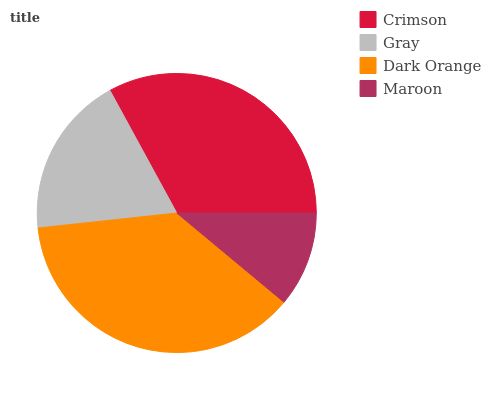Is Maroon the minimum?
Answer yes or no. Yes. Is Dark Orange the maximum?
Answer yes or no. Yes. Is Gray the minimum?
Answer yes or no. No. Is Gray the maximum?
Answer yes or no. No. Is Crimson greater than Gray?
Answer yes or no. Yes. Is Gray less than Crimson?
Answer yes or no. Yes. Is Gray greater than Crimson?
Answer yes or no. No. Is Crimson less than Gray?
Answer yes or no. No. Is Crimson the high median?
Answer yes or no. Yes. Is Gray the low median?
Answer yes or no. Yes. Is Maroon the high median?
Answer yes or no. No. Is Crimson the low median?
Answer yes or no. No. 